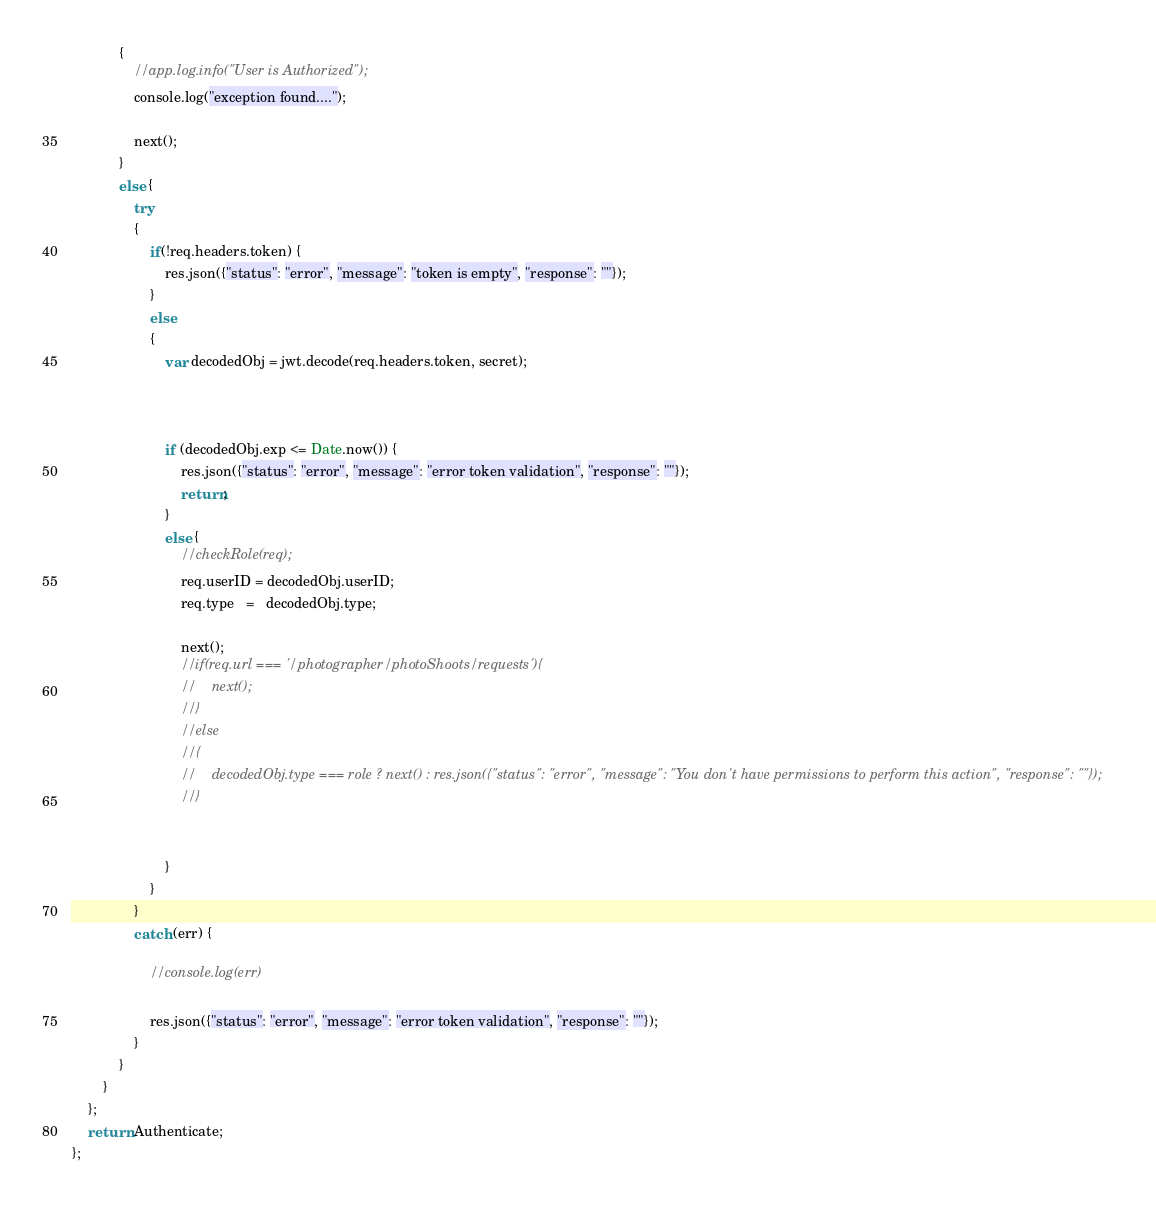Convert code to text. <code><loc_0><loc_0><loc_500><loc_500><_JavaScript_>            {
                //app.log.info("User is Authorized");
                console.log("exception found....");

                next();
            }
            else {
                try
                {
                    if(!req.headers.token) {
                        res.json({"status": "error", "message": "token is empty", "response": ""});
                    }
                    else
                    {
                        var decodedObj = jwt.decode(req.headers.token, secret);



                        if (decodedObj.exp <= Date.now()) {
                            res.json({"status": "error", "message": "error token validation", "response": ""});
                            return;
                        }
                        else {
                            //checkRole(req);
                            req.userID = decodedObj.userID;
                            req.type   =   decodedObj.type;

                            next();
                            //if(req.url === '/photographer/photoShoots/requests'){
                            //    next();
                            //}
                            //else
                            //{
                            //    decodedObj.type === role ? next() : res.json({"status": "error", "message": "You don't have permissions to perform this action", "response": ""});
                            //}


                        }
                    }
                }
                catch (err) {

                    //console.log(err)

                    res.json({"status": "error", "message": "error token validation", "response": ""});
                }
            }
        }
    };
    return Authenticate;
};
</code> 